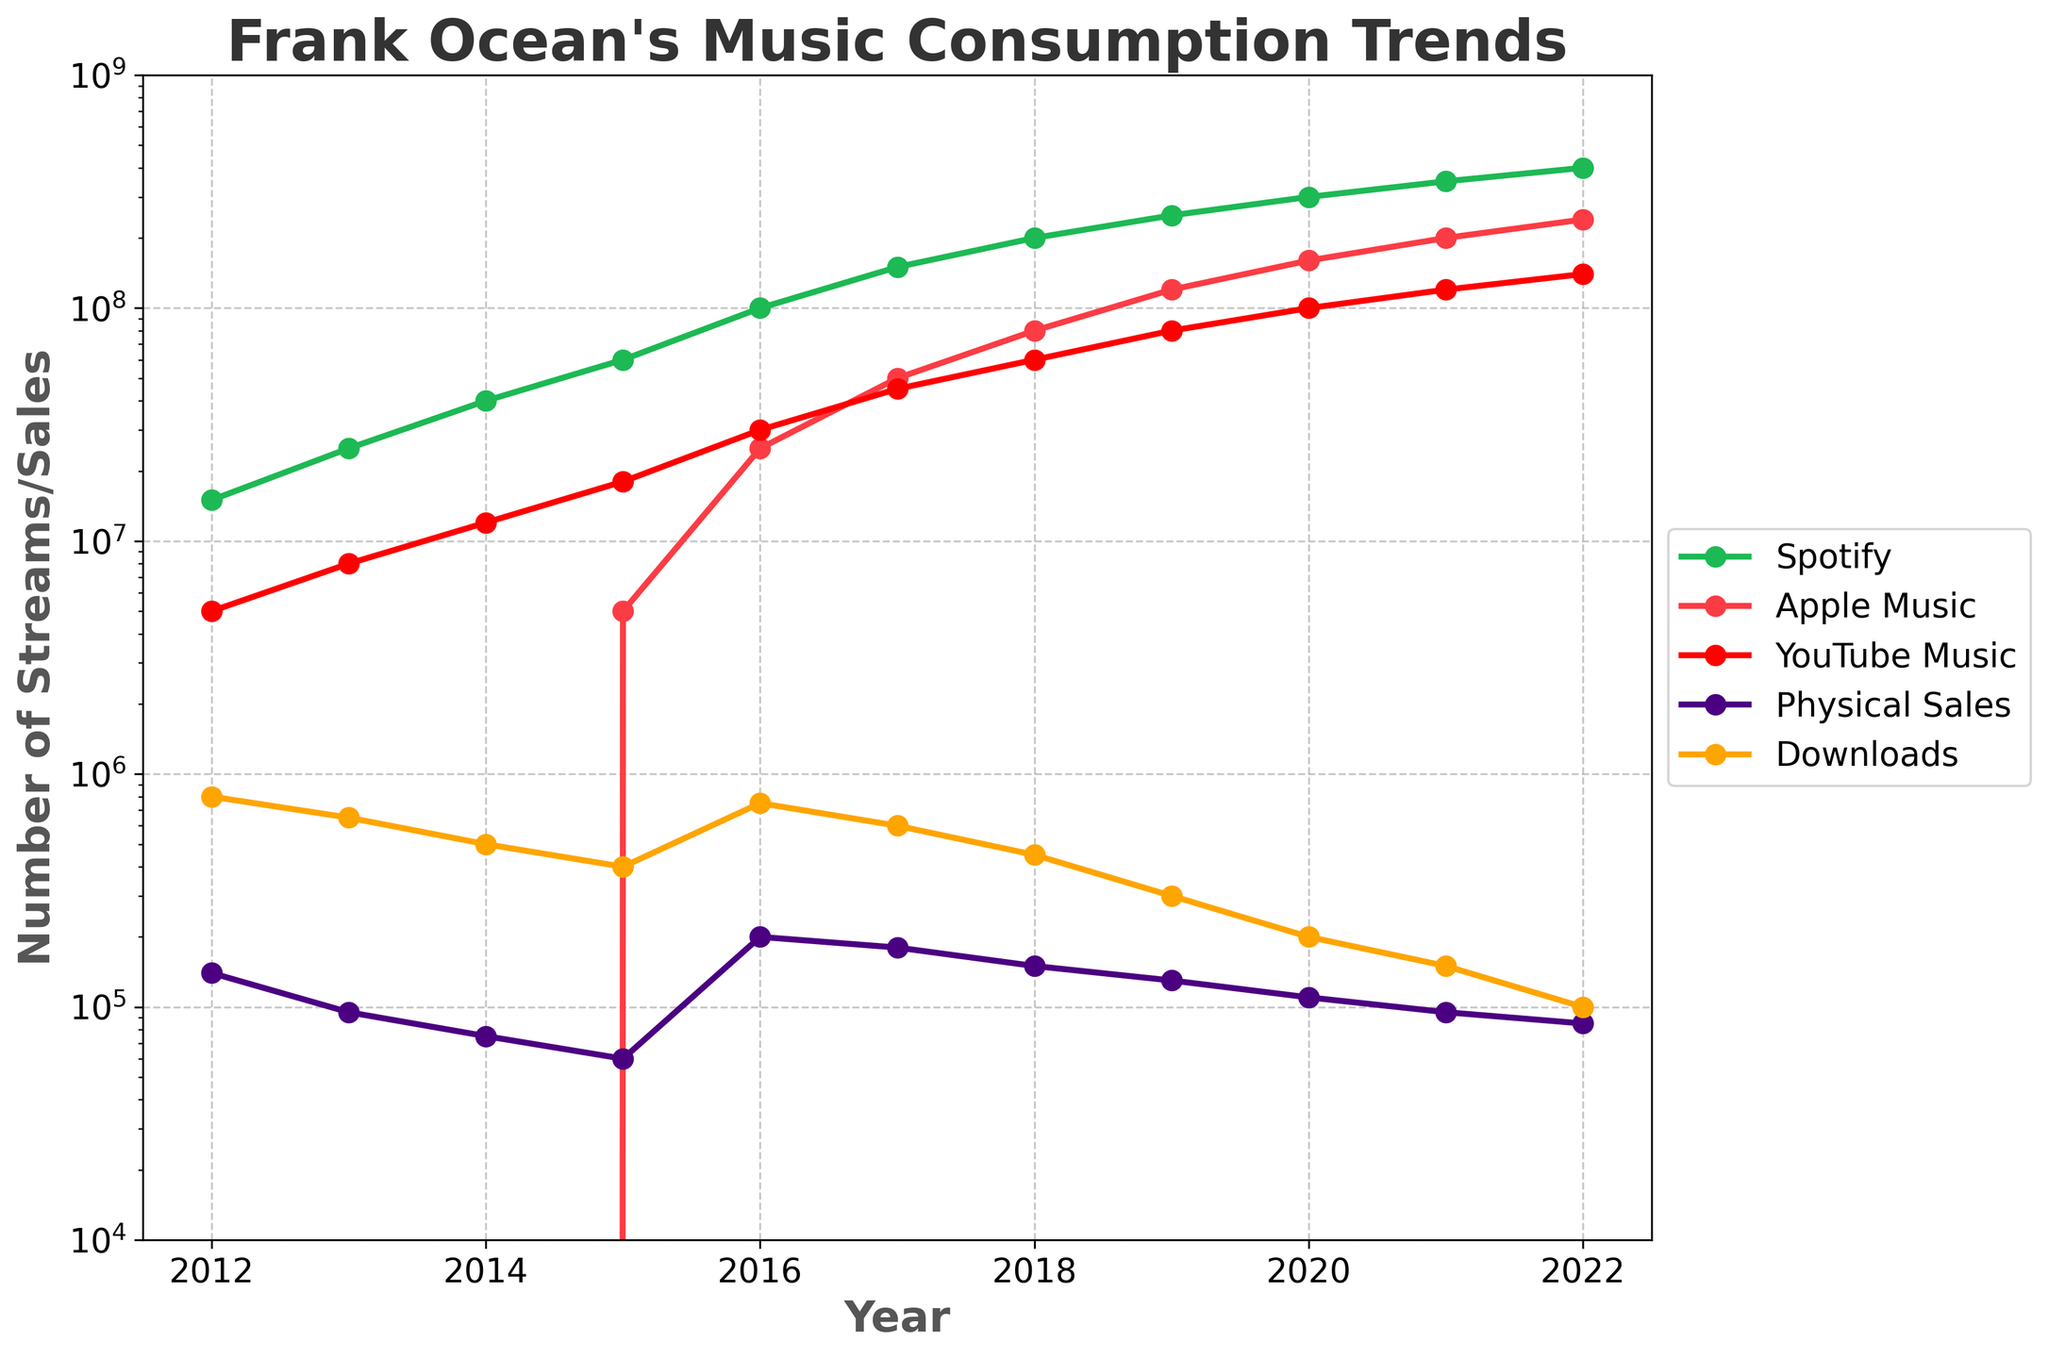What is the trend of Spotify streams from 2012 to 2022? To determine the trend, observe the plotted line corresponding to Spotify. Starting at 15,000,000 in 2012, the number of streams continuously increases, peaking at 400,000,000 in 2022.
Answer: Increasing How does the total number of streams across all online platforms (Spotify, Apple Music, YouTube Music) in 2022 compare to the total in 2018? Calculate the total for each year: In 2022, sum 400,000,000 (Spotify), 240,000,000 (Apple Music), and 140,000,000 (YouTube Music), which equals 780,000,000. In 2018, sum 200,000,000 (Spotify), 80,000,000 (Apple Music), and 60,000,000 (YouTube Music), which equals 340,000,000. In 2022, the total is significantly higher.
Answer: Higher in 2022 Which year showed the largest increase in Apple Music streams compared to the previous year? Compare the increase in Apple Music streams year by year. The largest increase occurred between 2017 (5,000,000) and 2018 (80,000,000), showing an increase of 75,000,000.
Answer: 2018 What are the colors of the lines representing Spotify and YouTube Music? Based on the provided color information, the line for Spotify is green and YouTube Music is red.
Answer: Green and Red What happens to the physical sales of Frank Ocean's albums from 2012 to 2022? Observe the line for Physical Sales, starting at 140,000 in 2012 and ending at 85,000 in 2022. Its trend shows a general decrease over this period.
Answer: Decreasing How does the trend of Downloads compare to that of Physical Sales? Both trends are generally decreasing from 2012 to 2022. Downloads start at 800,000 and end at 100,000, while Physical Sales start at 140,000 and end at 85,000.
Answer: Both Decreasing What's the difference in streams between Spotify and YouTube Music in 2021? For 2021: Subtract YouTube Music streams (120,000,000) from Spotify streams (350,000,000) to find a difference of 230,000,000.
Answer: 230,000,000 Which platform had zero streams at the beginning of the data collection and then saw a usage increase over time? Inspecting the plotted lines, only Apple Music starts from zero (in 2012) and shows a notable increase in subsequent years.
Answer: Apple Music What is the average number of streams for YouTube Music from 2016 to 2022? Calculate the average: Sum the streams from 2016 to 2022: (30,000,000 + 45,000,000 + 60,000,000 + 80,000,000 + 100,000,000 + 120,000,000 + 140,000,000) = 575,000,000. Divide by 7 years, resulting in approximately 82,142,857.
Answer: ~82,142,857 Which year had the highest overall music consumption across all listed platforms? Add each platform's consumption for each year. 2022 has the highest combination of all platforms' streams and sales, therefore, total music consumption is the highest in 2022.
Answer: 2022 